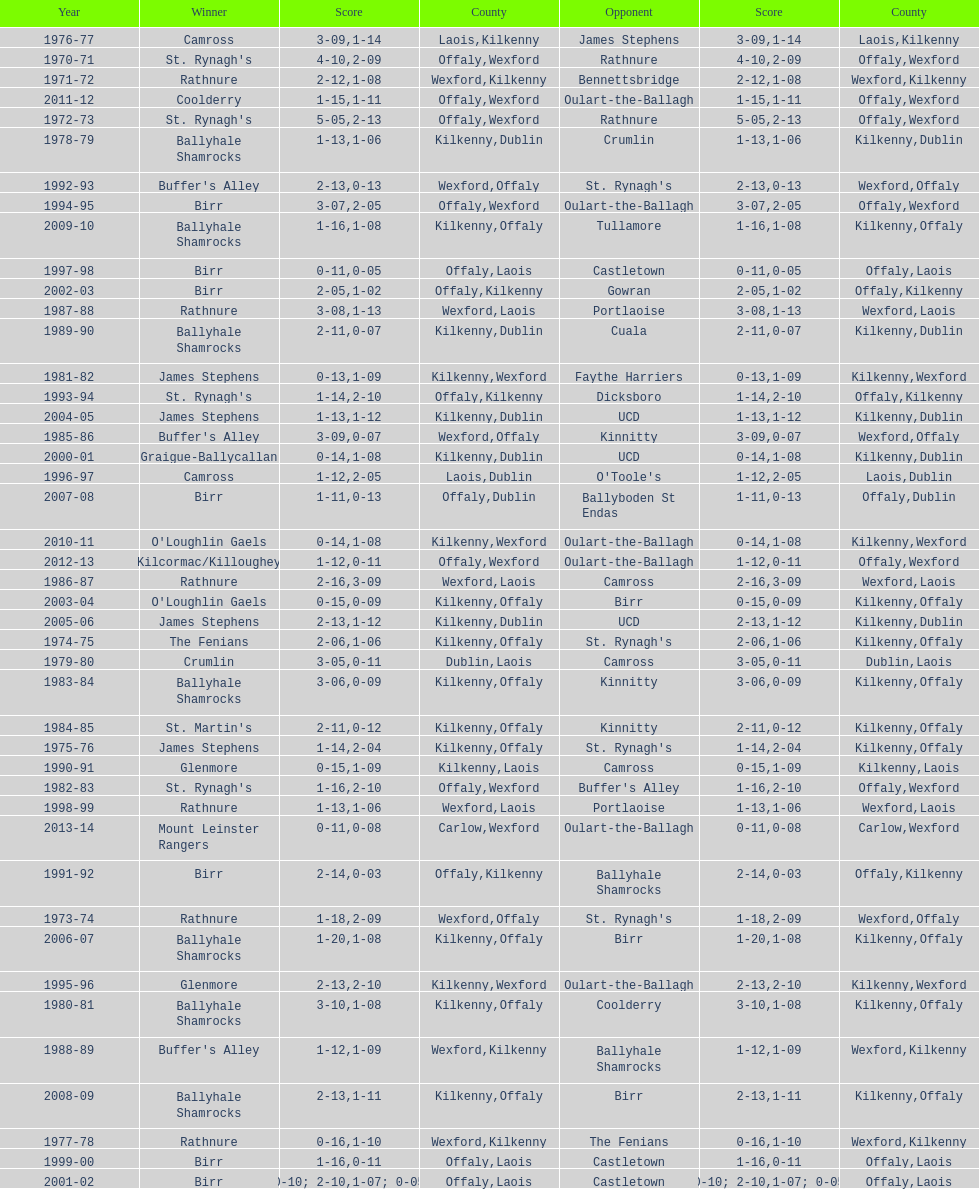How many consecutive years did rathnure win? 2. 